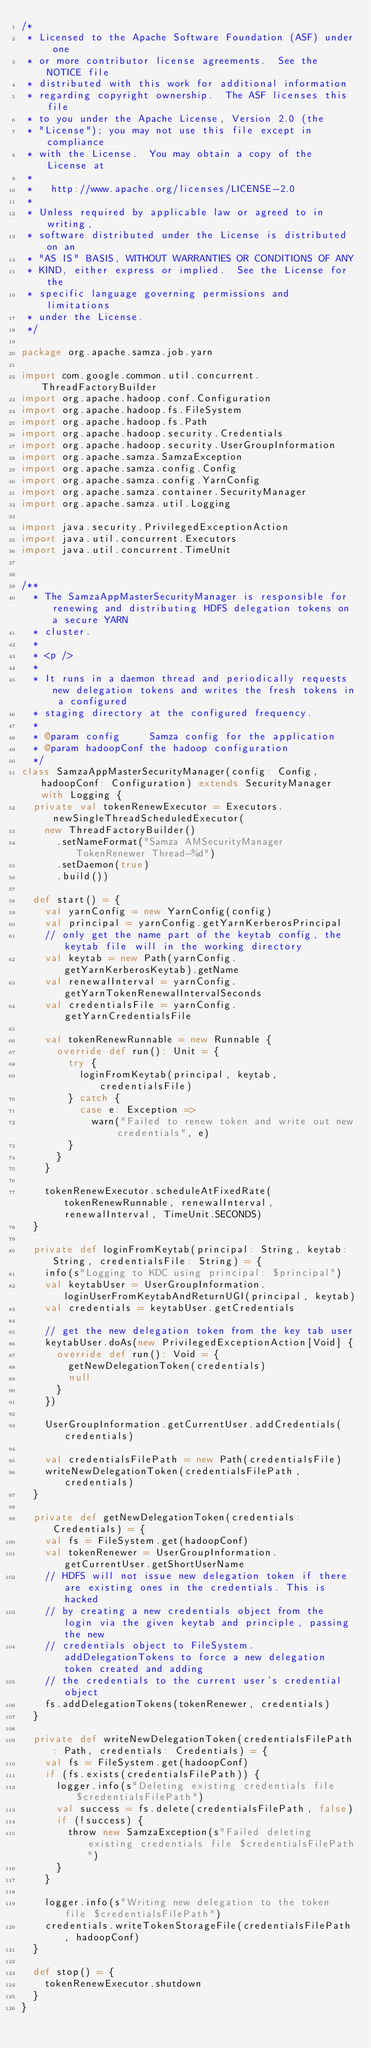<code> <loc_0><loc_0><loc_500><loc_500><_Scala_>/*
 * Licensed to the Apache Software Foundation (ASF) under one
 * or more contributor license agreements.  See the NOTICE file
 * distributed with this work for additional information
 * regarding copyright ownership.  The ASF licenses this file
 * to you under the Apache License, Version 2.0 (the
 * "License"); you may not use this file except in compliance
 * with the License.  You may obtain a copy of the License at
 *
 *   http://www.apache.org/licenses/LICENSE-2.0
 *
 * Unless required by applicable law or agreed to in writing,
 * software distributed under the License is distributed on an
 * "AS IS" BASIS, WITHOUT WARRANTIES OR CONDITIONS OF ANY
 * KIND, either express or implied.  See the License for the
 * specific language governing permissions and limitations
 * under the License.
 */

package org.apache.samza.job.yarn

import com.google.common.util.concurrent.ThreadFactoryBuilder
import org.apache.hadoop.conf.Configuration
import org.apache.hadoop.fs.FileSystem
import org.apache.hadoop.fs.Path
import org.apache.hadoop.security.Credentials
import org.apache.hadoop.security.UserGroupInformation
import org.apache.samza.SamzaException
import org.apache.samza.config.Config
import org.apache.samza.config.YarnConfig
import org.apache.samza.container.SecurityManager
import org.apache.samza.util.Logging

import java.security.PrivilegedExceptionAction
import java.util.concurrent.Executors
import java.util.concurrent.TimeUnit


/**
  * The SamzaAppMasterSecurityManager is responsible for renewing and distributing HDFS delegation tokens on a secure YARN
  * cluster.
  *
  * <p />
  *
  * It runs in a daemon thread and periodically requests new delegation tokens and writes the fresh tokens in a configured
  * staging directory at the configured frequency.
  *
  * @param config     Samza config for the application
  * @param hadoopConf the hadoop configuration
  */
class SamzaAppMasterSecurityManager(config: Config, hadoopConf: Configuration) extends SecurityManager with Logging {
  private val tokenRenewExecutor = Executors.newSingleThreadScheduledExecutor(
    new ThreadFactoryBuilder()
      .setNameFormat("Samza AMSecurityManager TokenRenewer Thread-%d")
      .setDaemon(true)
      .build())

  def start() = {
    val yarnConfig = new YarnConfig(config)
    val principal = yarnConfig.getYarnKerberosPrincipal
    // only get the name part of the keytab config, the keytab file will in the working directory
    val keytab = new Path(yarnConfig.getYarnKerberosKeytab).getName
    val renewalInterval = yarnConfig.getYarnTokenRenewalIntervalSeconds
    val credentialsFile = yarnConfig.getYarnCredentialsFile

    val tokenRenewRunnable = new Runnable {
      override def run(): Unit = {
        try {
          loginFromKeytab(principal, keytab, credentialsFile)
        } catch {
          case e: Exception =>
            warn("Failed to renew token and write out new credentials", e)
        }
      }
    }

    tokenRenewExecutor.scheduleAtFixedRate(tokenRenewRunnable, renewalInterval, renewalInterval, TimeUnit.SECONDS)
  }

  private def loginFromKeytab(principal: String, keytab: String, credentialsFile: String) = {
    info(s"Logging to KDC using principal: $principal")
    val keytabUser = UserGroupInformation.loginUserFromKeytabAndReturnUGI(principal, keytab)
    val credentials = keytabUser.getCredentials

    // get the new delegation token from the key tab user
    keytabUser.doAs(new PrivilegedExceptionAction[Void] {
      override def run(): Void = {
        getNewDelegationToken(credentials)
        null
      }
    })

    UserGroupInformation.getCurrentUser.addCredentials(credentials)

    val credentialsFilePath = new Path(credentialsFile)
    writeNewDelegationToken(credentialsFilePath, credentials)
  }

  private def getNewDelegationToken(credentials: Credentials) = {
    val fs = FileSystem.get(hadoopConf)
    val tokenRenewer = UserGroupInformation.getCurrentUser.getShortUserName
    // HDFS will not issue new delegation token if there are existing ones in the credentials. This is hacked
    // by creating a new credentials object from the login via the given keytab and principle, passing the new
    // credentials object to FileSystem.addDelegationTokens to force a new delegation token created and adding
    // the credentials to the current user's credential object
    fs.addDelegationTokens(tokenRenewer, credentials)
  }

  private def writeNewDelegationToken(credentialsFilePath: Path, credentials: Credentials) = {
    val fs = FileSystem.get(hadoopConf)
    if (fs.exists(credentialsFilePath)) {
      logger.info(s"Deleting existing credentials file $credentialsFilePath")
      val success = fs.delete(credentialsFilePath, false)
      if (!success) {
        throw new SamzaException(s"Failed deleting existing credentials file $credentialsFilePath")
      }
    }

    logger.info(s"Writing new delegation to the token file $credentialsFilePath")
    credentials.writeTokenStorageFile(credentialsFilePath, hadoopConf)
  }

  def stop() = {
    tokenRenewExecutor.shutdown
  }
}
</code> 